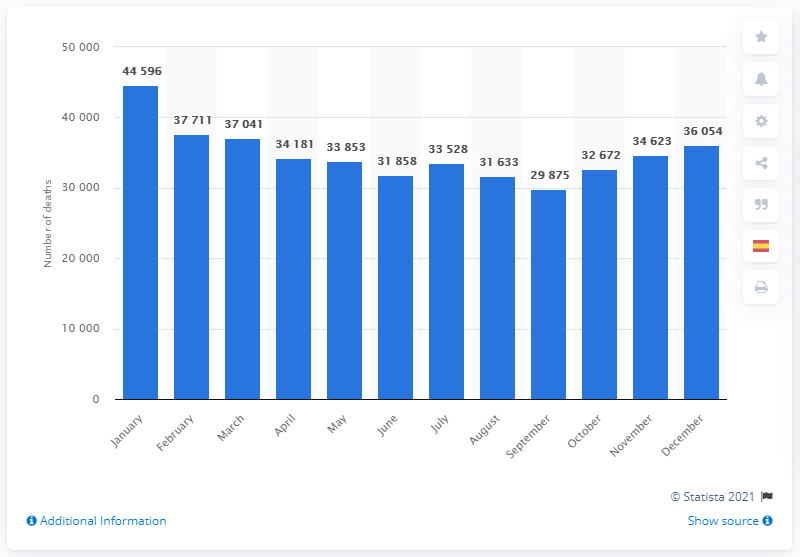Draw attention to some important aspects in this diagram. In 2019, January was the month with the highest number of deaths. In January, a total of 44,596 diseases were registered. The lowest number of deaths in September was 29,875. 